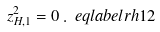<formula> <loc_0><loc_0><loc_500><loc_500>z _ { H , 1 } ^ { 2 } = 0 \, . \ e q l a b e l { r h 1 2 }</formula> 